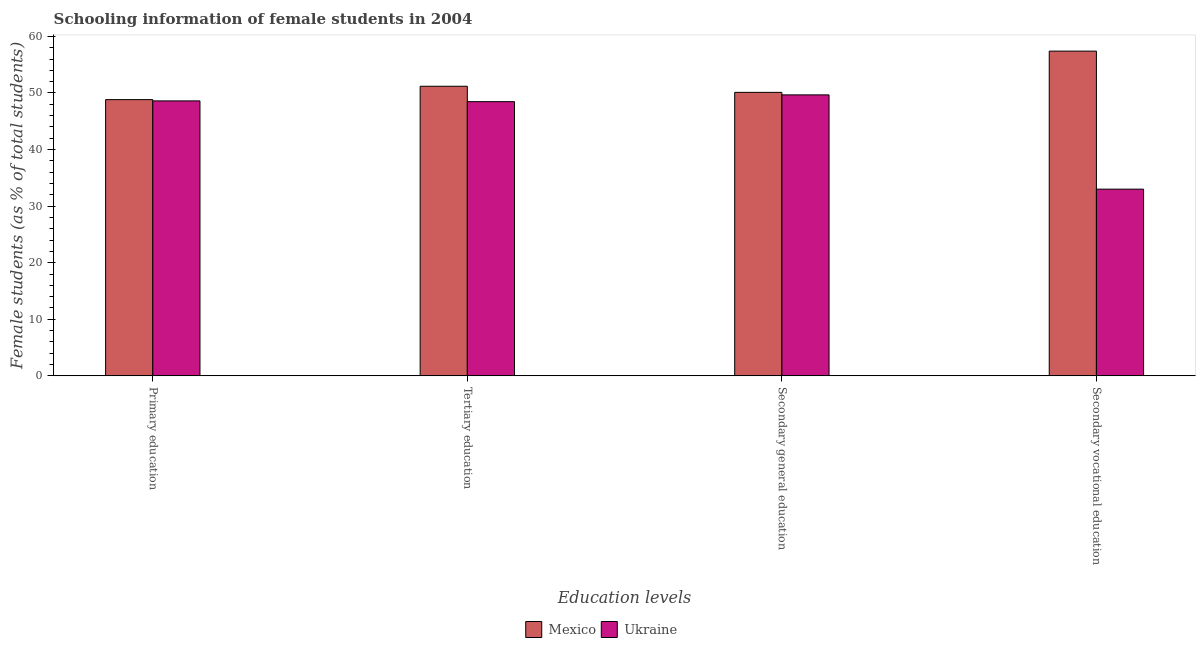Are the number of bars on each tick of the X-axis equal?
Give a very brief answer. Yes. How many bars are there on the 3rd tick from the left?
Offer a very short reply. 2. What is the label of the 3rd group of bars from the left?
Give a very brief answer. Secondary general education. What is the percentage of female students in secondary education in Mexico?
Provide a succinct answer. 50.11. Across all countries, what is the maximum percentage of female students in primary education?
Offer a very short reply. 48.82. Across all countries, what is the minimum percentage of female students in primary education?
Give a very brief answer. 48.6. In which country was the percentage of female students in primary education minimum?
Your answer should be compact. Ukraine. What is the total percentage of female students in secondary education in the graph?
Your response must be concise. 99.77. What is the difference between the percentage of female students in tertiary education in Mexico and that in Ukraine?
Your response must be concise. 2.72. What is the difference between the percentage of female students in tertiary education in Mexico and the percentage of female students in secondary vocational education in Ukraine?
Your answer should be very brief. 18.18. What is the average percentage of female students in tertiary education per country?
Ensure brevity in your answer.  49.82. What is the difference between the percentage of female students in secondary vocational education and percentage of female students in primary education in Ukraine?
Your response must be concise. -15.6. What is the ratio of the percentage of female students in secondary vocational education in Ukraine to that in Mexico?
Your answer should be compact. 0.57. Is the difference between the percentage of female students in secondary education in Ukraine and Mexico greater than the difference between the percentage of female students in primary education in Ukraine and Mexico?
Offer a very short reply. No. What is the difference between the highest and the second highest percentage of female students in secondary education?
Offer a terse response. 0.44. What is the difference between the highest and the lowest percentage of female students in secondary vocational education?
Your answer should be very brief. 24.4. Is the sum of the percentage of female students in tertiary education in Ukraine and Mexico greater than the maximum percentage of female students in primary education across all countries?
Offer a terse response. Yes. Is it the case that in every country, the sum of the percentage of female students in primary education and percentage of female students in secondary vocational education is greater than the sum of percentage of female students in secondary education and percentage of female students in tertiary education?
Make the answer very short. No. What does the 1st bar from the left in Secondary general education represents?
Keep it short and to the point. Mexico. What does the 2nd bar from the right in Primary education represents?
Keep it short and to the point. Mexico. Is it the case that in every country, the sum of the percentage of female students in primary education and percentage of female students in tertiary education is greater than the percentage of female students in secondary education?
Make the answer very short. Yes. Are all the bars in the graph horizontal?
Keep it short and to the point. No. Does the graph contain grids?
Keep it short and to the point. No. Where does the legend appear in the graph?
Your answer should be compact. Bottom center. How many legend labels are there?
Ensure brevity in your answer.  2. How are the legend labels stacked?
Make the answer very short. Horizontal. What is the title of the graph?
Offer a terse response. Schooling information of female students in 2004. What is the label or title of the X-axis?
Ensure brevity in your answer.  Education levels. What is the label or title of the Y-axis?
Your response must be concise. Female students (as % of total students). What is the Female students (as % of total students) of Mexico in Primary education?
Your answer should be compact. 48.82. What is the Female students (as % of total students) of Ukraine in Primary education?
Ensure brevity in your answer.  48.6. What is the Female students (as % of total students) in Mexico in Tertiary education?
Your answer should be compact. 51.18. What is the Female students (as % of total students) of Ukraine in Tertiary education?
Provide a succinct answer. 48.46. What is the Female students (as % of total students) in Mexico in Secondary general education?
Your answer should be very brief. 50.11. What is the Female students (as % of total students) of Ukraine in Secondary general education?
Your answer should be compact. 49.66. What is the Female students (as % of total students) in Mexico in Secondary vocational education?
Ensure brevity in your answer.  57.4. What is the Female students (as % of total students) of Ukraine in Secondary vocational education?
Your answer should be very brief. 33. Across all Education levels, what is the maximum Female students (as % of total students) in Mexico?
Ensure brevity in your answer.  57.4. Across all Education levels, what is the maximum Female students (as % of total students) in Ukraine?
Keep it short and to the point. 49.66. Across all Education levels, what is the minimum Female students (as % of total students) of Mexico?
Offer a terse response. 48.82. Across all Education levels, what is the minimum Female students (as % of total students) in Ukraine?
Provide a short and direct response. 33. What is the total Female students (as % of total students) of Mexico in the graph?
Offer a terse response. 207.51. What is the total Female students (as % of total students) in Ukraine in the graph?
Ensure brevity in your answer.  179.72. What is the difference between the Female students (as % of total students) of Mexico in Primary education and that in Tertiary education?
Provide a succinct answer. -2.36. What is the difference between the Female students (as % of total students) of Ukraine in Primary education and that in Tertiary education?
Provide a succinct answer. 0.13. What is the difference between the Female students (as % of total students) in Mexico in Primary education and that in Secondary general education?
Make the answer very short. -1.28. What is the difference between the Female students (as % of total students) in Ukraine in Primary education and that in Secondary general education?
Your answer should be compact. -1.06. What is the difference between the Female students (as % of total students) of Mexico in Primary education and that in Secondary vocational education?
Your answer should be very brief. -8.58. What is the difference between the Female students (as % of total students) of Ukraine in Primary education and that in Secondary vocational education?
Your answer should be compact. 15.6. What is the difference between the Female students (as % of total students) in Mexico in Tertiary education and that in Secondary general education?
Offer a terse response. 1.08. What is the difference between the Female students (as % of total students) of Ukraine in Tertiary education and that in Secondary general education?
Your answer should be compact. -1.2. What is the difference between the Female students (as % of total students) in Mexico in Tertiary education and that in Secondary vocational education?
Ensure brevity in your answer.  -6.21. What is the difference between the Female students (as % of total students) in Ukraine in Tertiary education and that in Secondary vocational education?
Your response must be concise. 15.46. What is the difference between the Female students (as % of total students) in Mexico in Secondary general education and that in Secondary vocational education?
Offer a very short reply. -7.29. What is the difference between the Female students (as % of total students) in Ukraine in Secondary general education and that in Secondary vocational education?
Provide a short and direct response. 16.66. What is the difference between the Female students (as % of total students) of Mexico in Primary education and the Female students (as % of total students) of Ukraine in Tertiary education?
Provide a short and direct response. 0.36. What is the difference between the Female students (as % of total students) in Mexico in Primary education and the Female students (as % of total students) in Ukraine in Secondary general education?
Ensure brevity in your answer.  -0.84. What is the difference between the Female students (as % of total students) in Mexico in Primary education and the Female students (as % of total students) in Ukraine in Secondary vocational education?
Make the answer very short. 15.82. What is the difference between the Female students (as % of total students) in Mexico in Tertiary education and the Female students (as % of total students) in Ukraine in Secondary general education?
Your answer should be compact. 1.52. What is the difference between the Female students (as % of total students) in Mexico in Tertiary education and the Female students (as % of total students) in Ukraine in Secondary vocational education?
Your answer should be very brief. 18.18. What is the difference between the Female students (as % of total students) in Mexico in Secondary general education and the Female students (as % of total students) in Ukraine in Secondary vocational education?
Your response must be concise. 17.11. What is the average Female students (as % of total students) in Mexico per Education levels?
Offer a very short reply. 51.88. What is the average Female students (as % of total students) in Ukraine per Education levels?
Give a very brief answer. 44.93. What is the difference between the Female students (as % of total students) of Mexico and Female students (as % of total students) of Ukraine in Primary education?
Your answer should be very brief. 0.22. What is the difference between the Female students (as % of total students) of Mexico and Female students (as % of total students) of Ukraine in Tertiary education?
Your response must be concise. 2.72. What is the difference between the Female students (as % of total students) in Mexico and Female students (as % of total students) in Ukraine in Secondary general education?
Give a very brief answer. 0.44. What is the difference between the Female students (as % of total students) in Mexico and Female students (as % of total students) in Ukraine in Secondary vocational education?
Provide a short and direct response. 24.4. What is the ratio of the Female students (as % of total students) of Mexico in Primary education to that in Tertiary education?
Offer a terse response. 0.95. What is the ratio of the Female students (as % of total students) in Mexico in Primary education to that in Secondary general education?
Your response must be concise. 0.97. What is the ratio of the Female students (as % of total students) of Ukraine in Primary education to that in Secondary general education?
Provide a succinct answer. 0.98. What is the ratio of the Female students (as % of total students) of Mexico in Primary education to that in Secondary vocational education?
Give a very brief answer. 0.85. What is the ratio of the Female students (as % of total students) of Ukraine in Primary education to that in Secondary vocational education?
Your response must be concise. 1.47. What is the ratio of the Female students (as % of total students) in Mexico in Tertiary education to that in Secondary general education?
Offer a very short reply. 1.02. What is the ratio of the Female students (as % of total students) in Ukraine in Tertiary education to that in Secondary general education?
Provide a short and direct response. 0.98. What is the ratio of the Female students (as % of total students) of Mexico in Tertiary education to that in Secondary vocational education?
Your answer should be compact. 0.89. What is the ratio of the Female students (as % of total students) of Ukraine in Tertiary education to that in Secondary vocational education?
Ensure brevity in your answer.  1.47. What is the ratio of the Female students (as % of total students) in Mexico in Secondary general education to that in Secondary vocational education?
Offer a very short reply. 0.87. What is the ratio of the Female students (as % of total students) of Ukraine in Secondary general education to that in Secondary vocational education?
Offer a terse response. 1.5. What is the difference between the highest and the second highest Female students (as % of total students) of Mexico?
Your answer should be very brief. 6.21. What is the difference between the highest and the second highest Female students (as % of total students) of Ukraine?
Keep it short and to the point. 1.06. What is the difference between the highest and the lowest Female students (as % of total students) in Mexico?
Provide a short and direct response. 8.58. What is the difference between the highest and the lowest Female students (as % of total students) of Ukraine?
Offer a terse response. 16.66. 